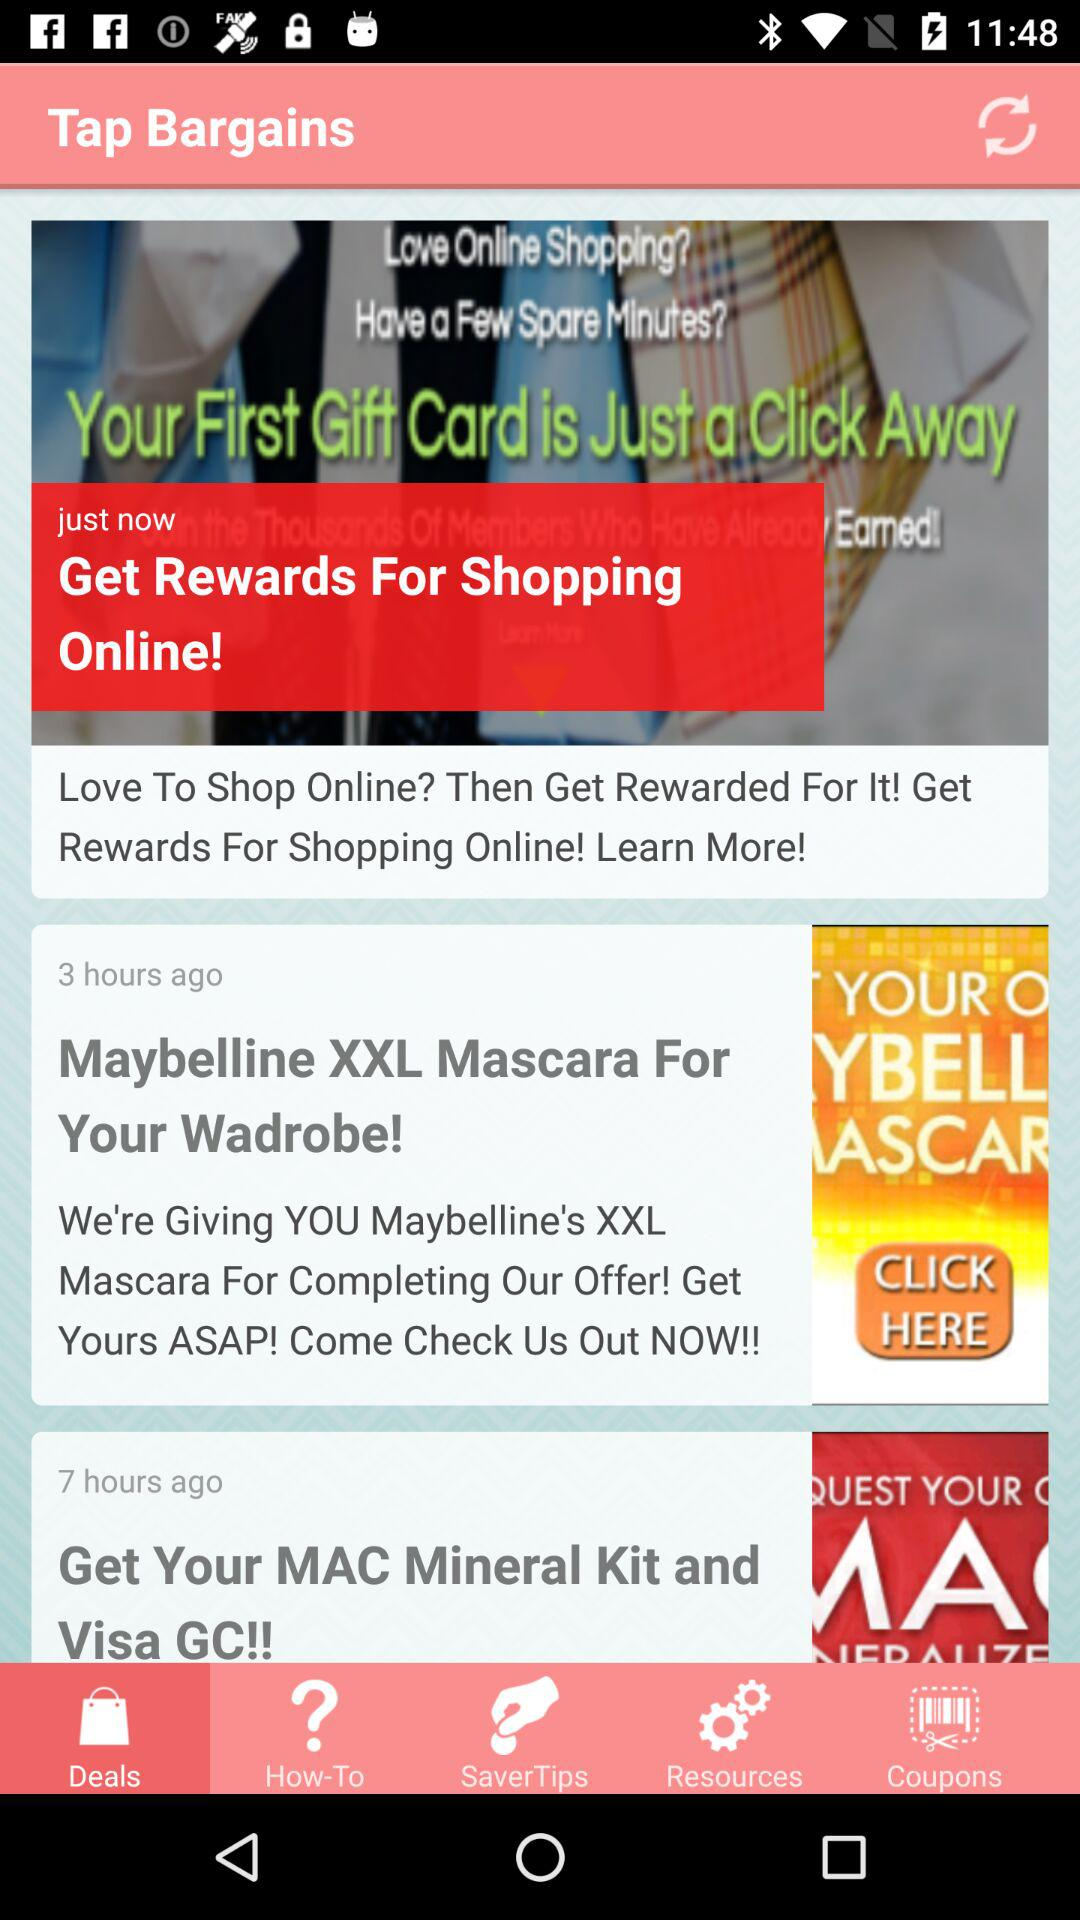When was the "Maybelline XXL Mascara For Your Wadrobe!" posted? The "Maybelline XXL Mascara For Your Wadrobe!" was posted 3 hours ago. 